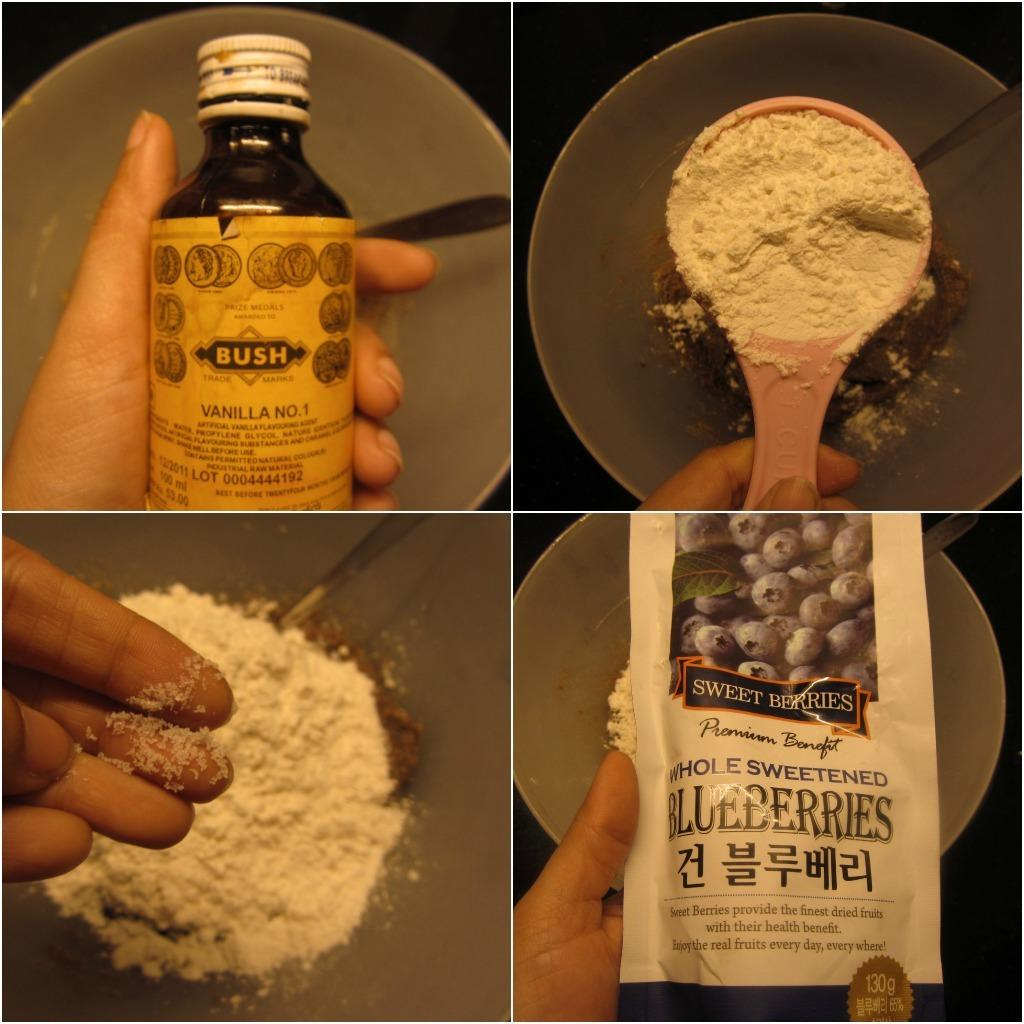<image>
Describe the image concisely. A person shows ingredients such as vanilla and blueberries being added to a mixing bowl. 